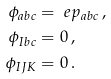<formula> <loc_0><loc_0><loc_500><loc_500>\phi _ { a b c } & = \ e p _ { a b c } \, , \\ \phi _ { I b c } & = 0 \, , \\ \phi _ { I J K } & = 0 \, .</formula> 